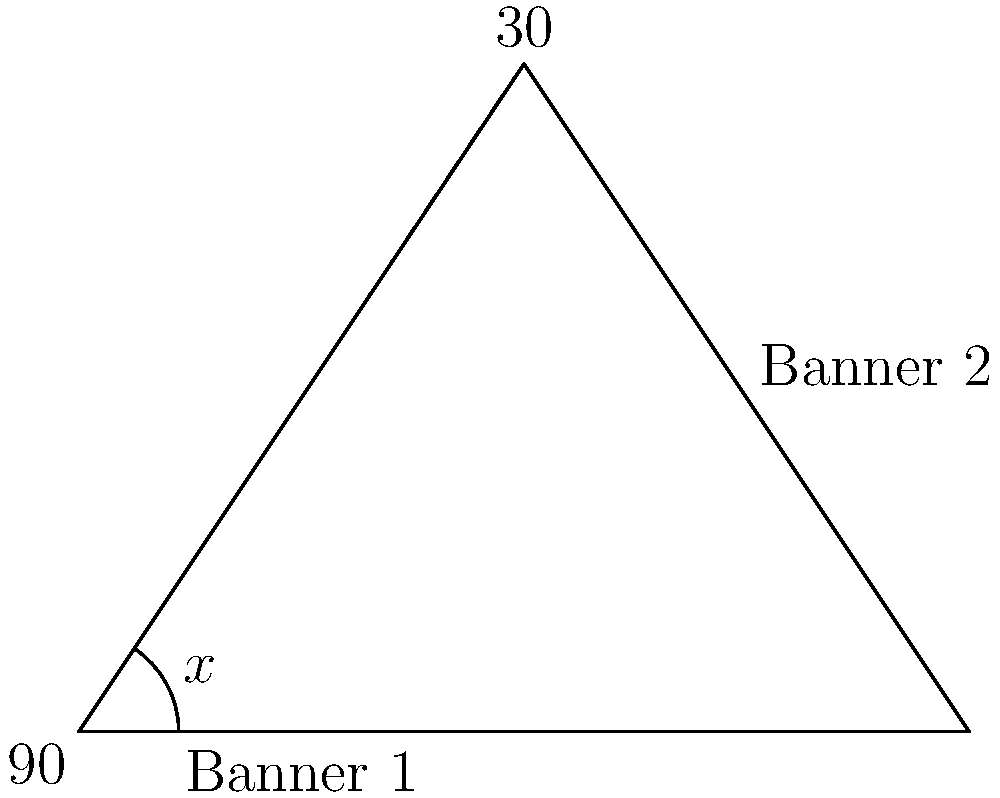Two prayer banners are hung from the ceiling, intersecting at a right angle. One banner forms a 30° angle with the vertical. What is the angle $x$ between the two banners? Let's approach this step-by-step:

1) The two banners form a right angle (90°) where they intersect at the ceiling.

2) One banner is at a 30° angle from the vertical. This means it's at a 60° angle from the horizontal (since 90° - 30° = 60°).

3) We now have a right-angled triangle where:
   - The right angle (90°) is at the point where the banners meet the ceiling
   - One angle is 60° (the angle between the horizontal and Banner 1)
   - The third angle is the one we're looking for, let's call it $x$

4) In a triangle, the sum of all angles is always 180°. So we can set up an equation:

   $90° + 60° + x° = 180°$

5) Simplify:
   $150° + x° = 180°$

6) Subtract 150° from both sides:
   $x° = 180° - 150° = 30°$

Therefore, the angle $x$ between the two banners is 30°.
Answer: $30°$ 